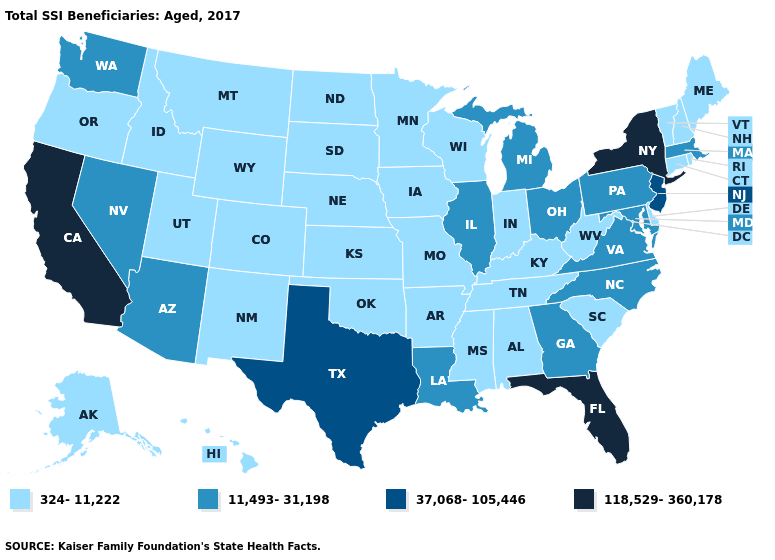Is the legend a continuous bar?
Give a very brief answer. No. Does Montana have a lower value than South Carolina?
Write a very short answer. No. What is the value of Hawaii?
Give a very brief answer. 324-11,222. Does the first symbol in the legend represent the smallest category?
Keep it brief. Yes. What is the value of North Dakota?
Concise answer only. 324-11,222. What is the value of Delaware?
Be succinct. 324-11,222. What is the value of Iowa?
Answer briefly. 324-11,222. Does Kansas have the same value as Arkansas?
Give a very brief answer. Yes. What is the value of Iowa?
Short answer required. 324-11,222. Name the states that have a value in the range 11,493-31,198?
Short answer required. Arizona, Georgia, Illinois, Louisiana, Maryland, Massachusetts, Michigan, Nevada, North Carolina, Ohio, Pennsylvania, Virginia, Washington. Among the states that border New York , does Connecticut have the lowest value?
Write a very short answer. Yes. Name the states that have a value in the range 324-11,222?
Concise answer only. Alabama, Alaska, Arkansas, Colorado, Connecticut, Delaware, Hawaii, Idaho, Indiana, Iowa, Kansas, Kentucky, Maine, Minnesota, Mississippi, Missouri, Montana, Nebraska, New Hampshire, New Mexico, North Dakota, Oklahoma, Oregon, Rhode Island, South Carolina, South Dakota, Tennessee, Utah, Vermont, West Virginia, Wisconsin, Wyoming. Among the states that border New York , does Massachusetts have the lowest value?
Concise answer only. No. What is the value of Washington?
Concise answer only. 11,493-31,198. Which states have the lowest value in the USA?
Short answer required. Alabama, Alaska, Arkansas, Colorado, Connecticut, Delaware, Hawaii, Idaho, Indiana, Iowa, Kansas, Kentucky, Maine, Minnesota, Mississippi, Missouri, Montana, Nebraska, New Hampshire, New Mexico, North Dakota, Oklahoma, Oregon, Rhode Island, South Carolina, South Dakota, Tennessee, Utah, Vermont, West Virginia, Wisconsin, Wyoming. 